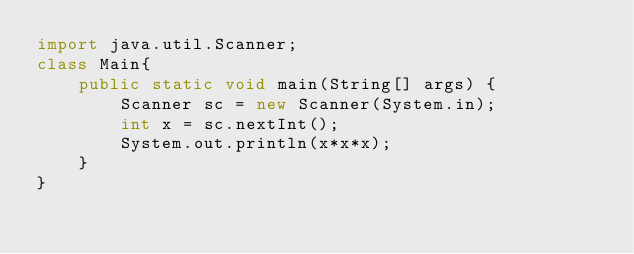Convert code to text. <code><loc_0><loc_0><loc_500><loc_500><_Java_>import java.util.Scanner;
class Main{
    public static void main(String[] args) {
        Scanner sc = new Scanner(System.in);
        int x = sc.nextInt();
        System.out.println(x*x*x);
    }
}
</code> 